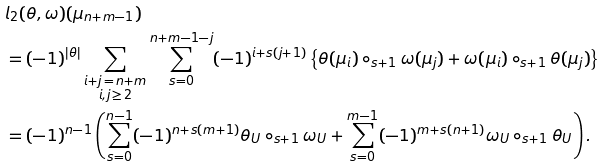<formula> <loc_0><loc_0><loc_500><loc_500>& l _ { 2 } ( \theta , \omega ) ( \mu _ { n + m - 1 } ) \\ & = ( - 1 ) ^ { | \theta | } \sum _ { \substack { i + j \, = \, n + m \\ i , j \, \geq \, 2 } } \sum _ { s = 0 } ^ { n + m - 1 - j } ( - 1 ) ^ { i + s ( j + 1 ) } \left \{ \theta ( \mu _ { i } ) \circ _ { s + 1 } \omega ( \mu _ { j } ) + \omega ( \mu _ { i } ) \circ _ { s + 1 } \theta ( \mu _ { j } ) \right \} \\ & = ( - 1 ) ^ { n - 1 } \left ( \sum _ { s = 0 } ^ { n - 1 } ( - 1 ) ^ { n + s ( m + 1 ) } \theta _ { U } \circ _ { s + 1 } \omega _ { U } + \sum _ { s = 0 } ^ { m - 1 } ( - 1 ) ^ { m + s ( n + 1 ) } \omega _ { U } \circ _ { s + 1 } \theta _ { U } \right ) .</formula> 